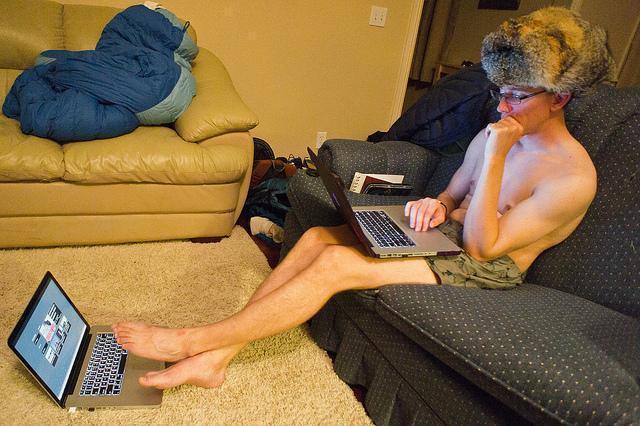What area of the computer is he touching with his fingers?
Select the accurate answer and provide justification: `Answer: choice
Rationale: srationale.`
Options: Trackpad, screen, keyboard, usb slot. Answer: trackpad.
Rationale: He is using this to move the cursor. 